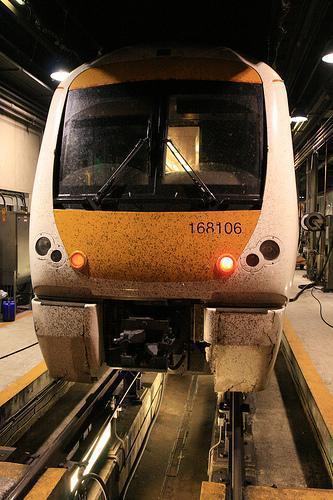How many trains are there?
Give a very brief answer. 1. 